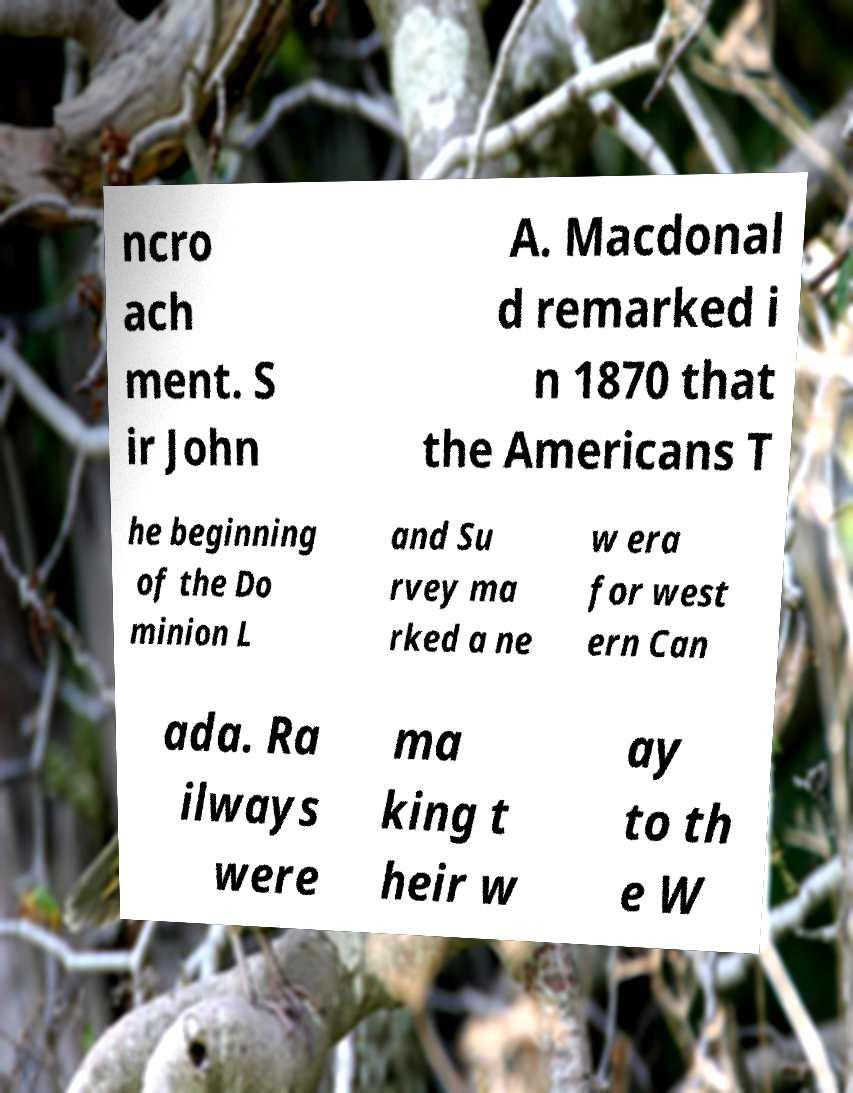For documentation purposes, I need the text within this image transcribed. Could you provide that? ncro ach ment. S ir John A. Macdonal d remarked i n 1870 that the Americans T he beginning of the Do minion L and Su rvey ma rked a ne w era for west ern Can ada. Ra ilways were ma king t heir w ay to th e W 